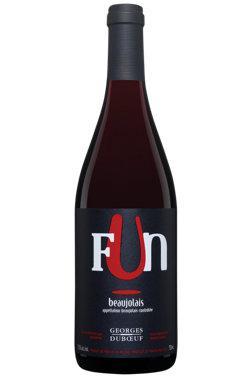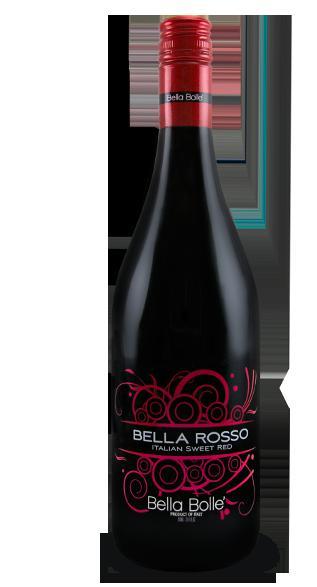The first image is the image on the left, the second image is the image on the right. Analyze the images presented: Is the assertion "All bottles are dark with red trim and withthe same long-necked shape." valid? Answer yes or no. Yes. 